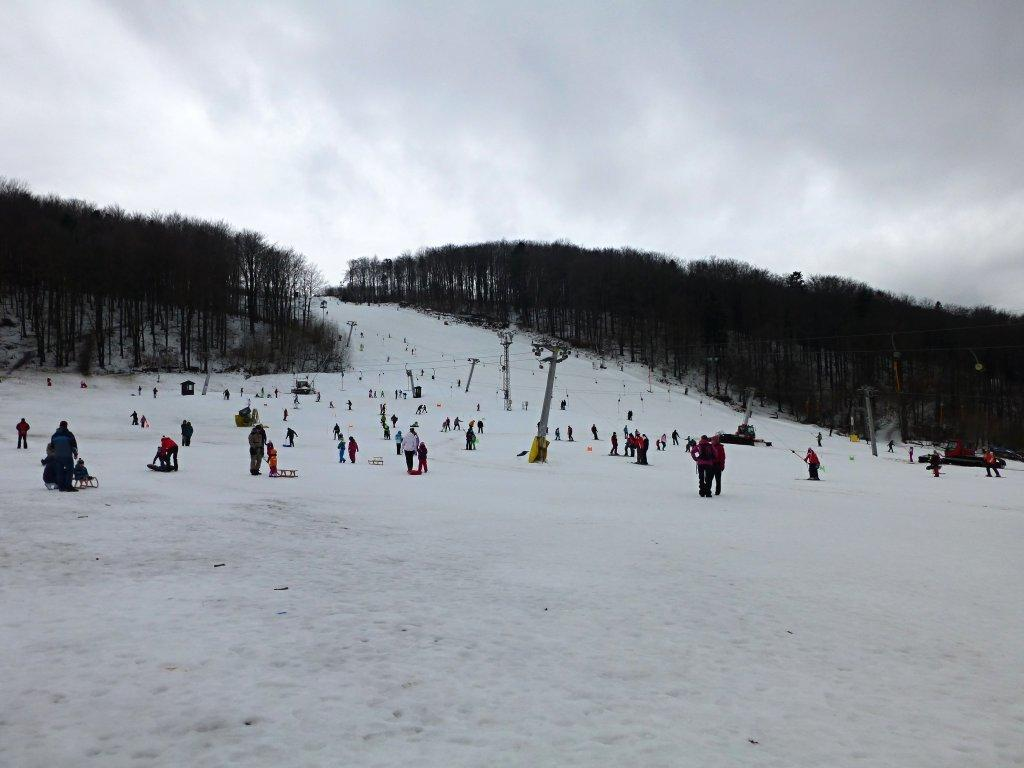What are the people in the image doing? There are people standing and sitting in snow vehicles in the image. What type of environment is depicted in the image? The image appears to be set on a snowy mountain. What can be seen in the background of the image? There are trees visible in the image. What information is being conveyed in the image? The image depicts current polls. Where is the pail located in the image? There is no pail present in the image. What type of camp can be seen in the image? There is no camp present in the image. 